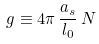Convert formula to latex. <formula><loc_0><loc_0><loc_500><loc_500>g \equiv 4 \pi \, \frac { a _ { s } } { l _ { 0 } } \, N</formula> 